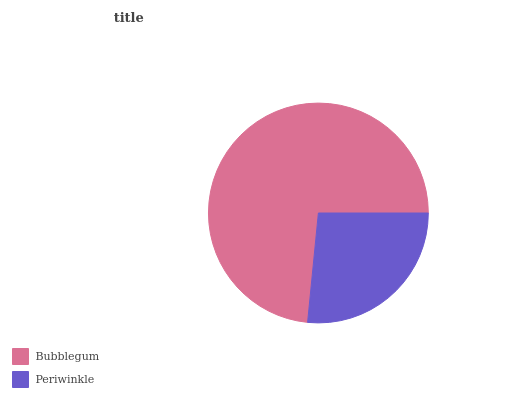Is Periwinkle the minimum?
Answer yes or no. Yes. Is Bubblegum the maximum?
Answer yes or no. Yes. Is Periwinkle the maximum?
Answer yes or no. No. Is Bubblegum greater than Periwinkle?
Answer yes or no. Yes. Is Periwinkle less than Bubblegum?
Answer yes or no. Yes. Is Periwinkle greater than Bubblegum?
Answer yes or no. No. Is Bubblegum less than Periwinkle?
Answer yes or no. No. Is Bubblegum the high median?
Answer yes or no. Yes. Is Periwinkle the low median?
Answer yes or no. Yes. Is Periwinkle the high median?
Answer yes or no. No. Is Bubblegum the low median?
Answer yes or no. No. 